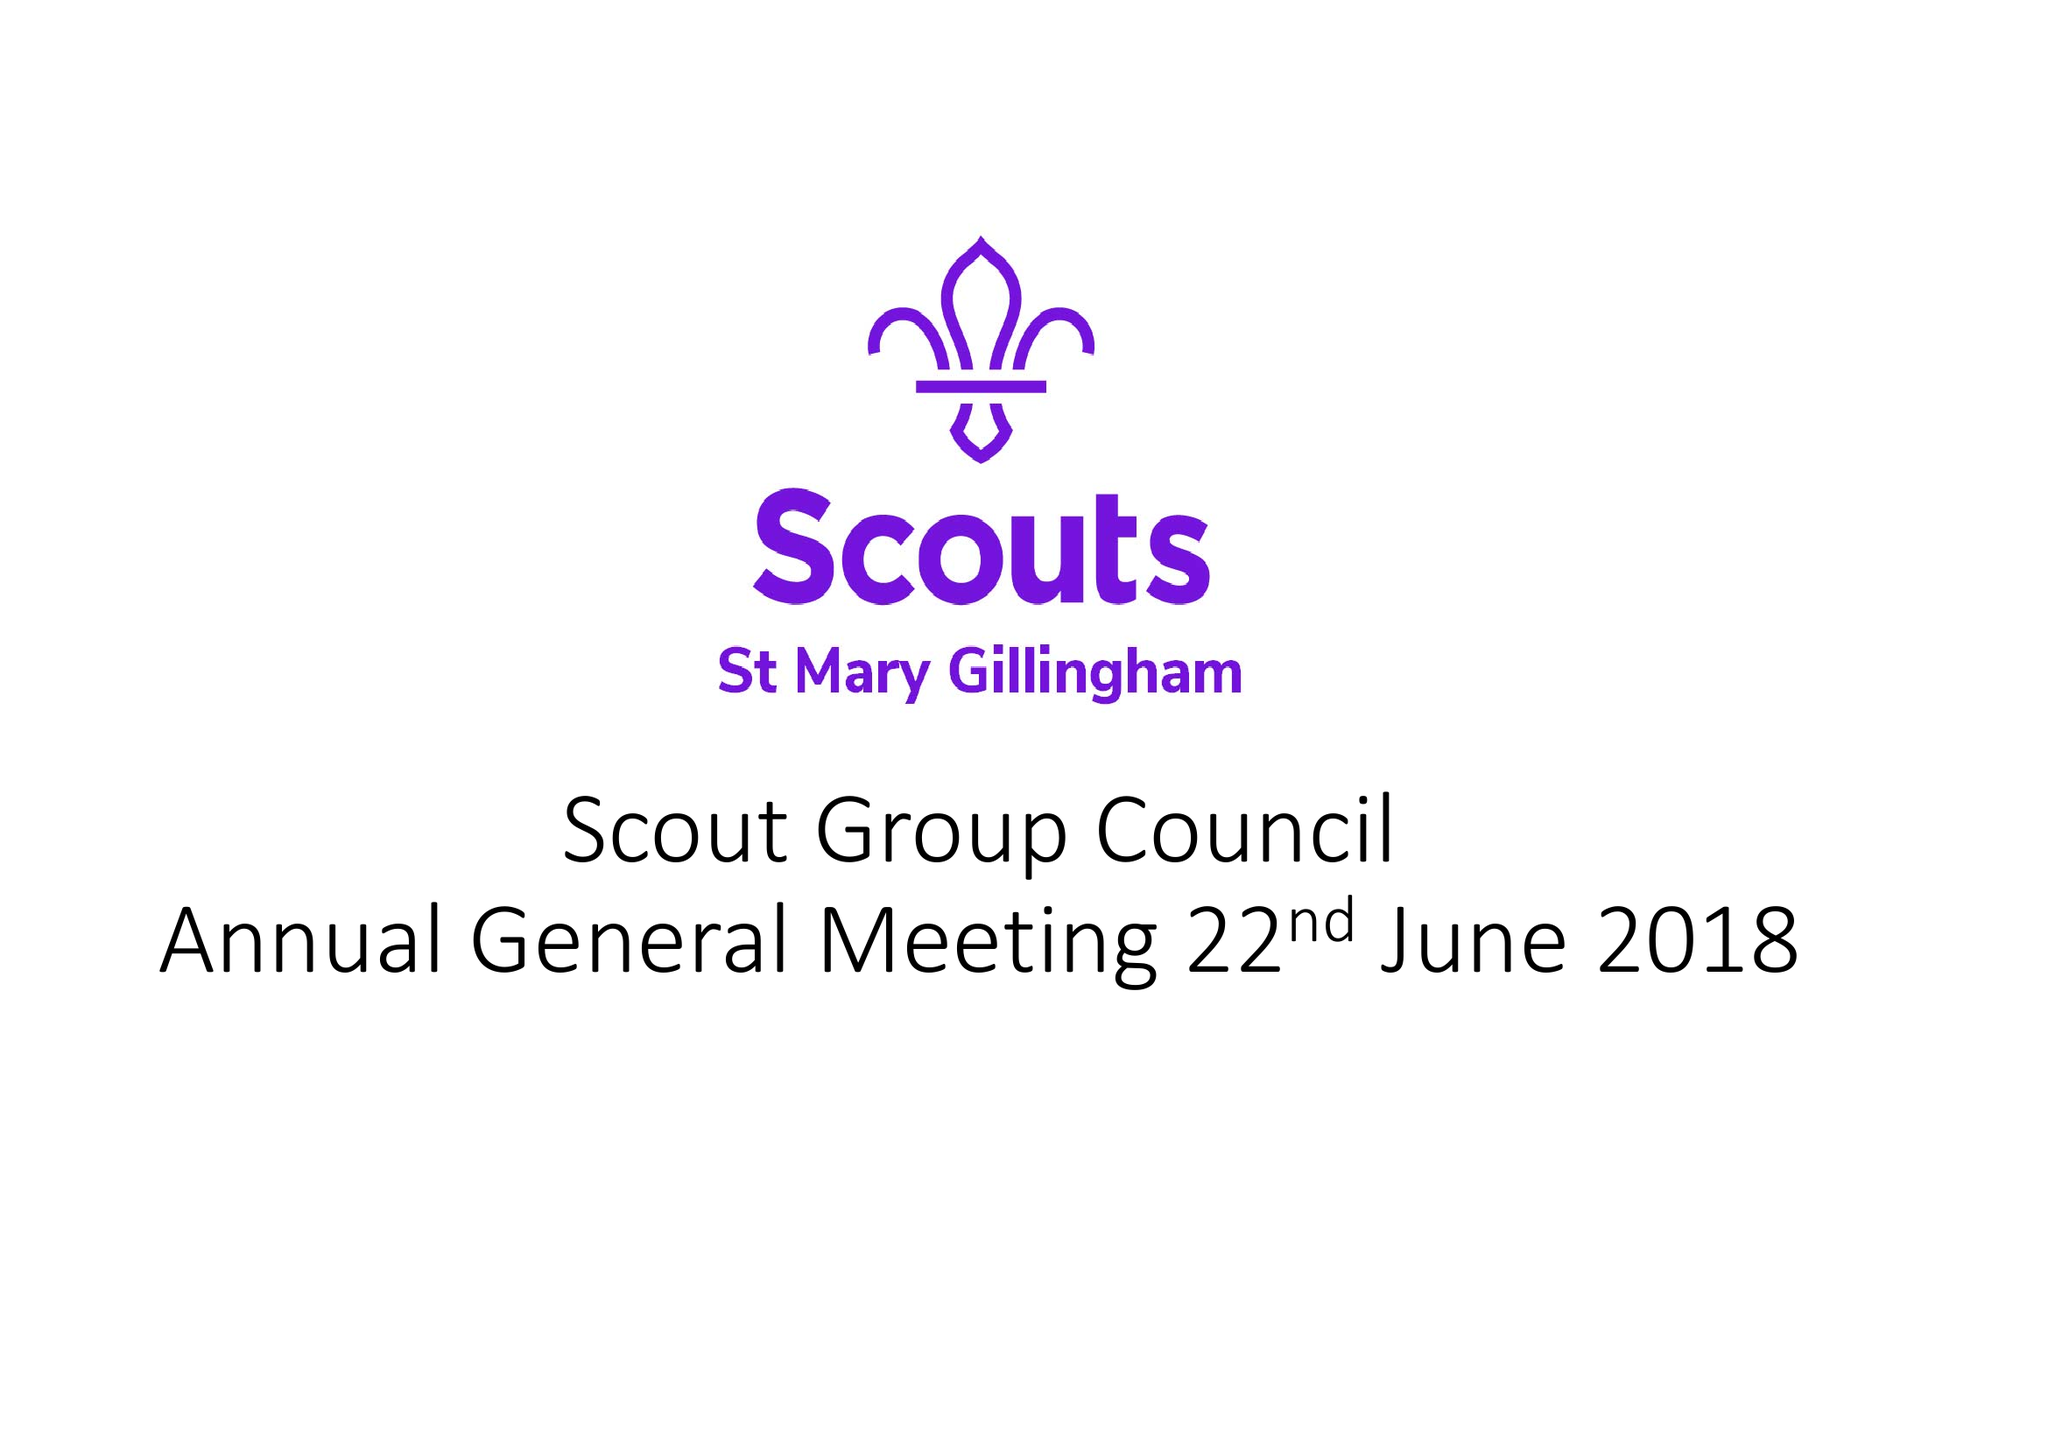What is the value for the address__street_line?
Answer the question using a single word or phrase. None 